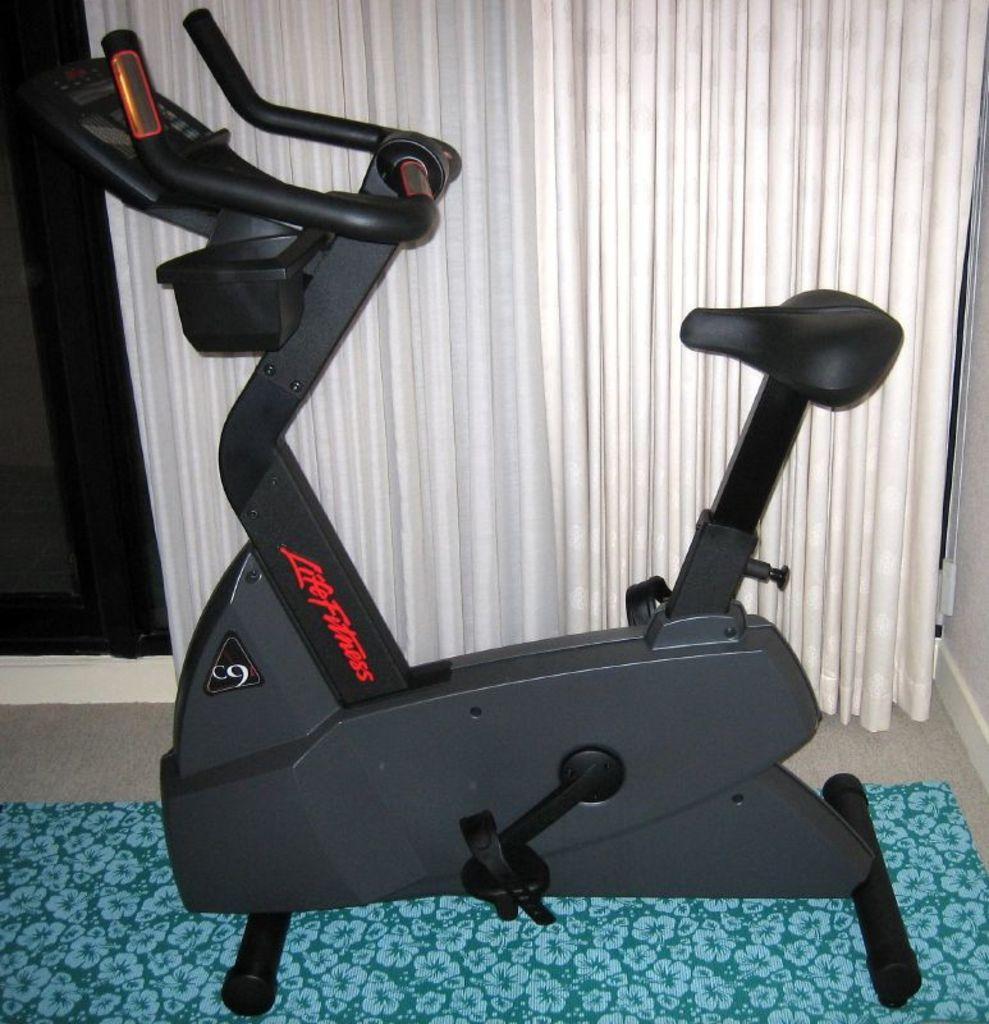Please provide a concise description of this image. In the image we can see there is a bicycle exercise machine kept on the floor and behind there are white curtains. 